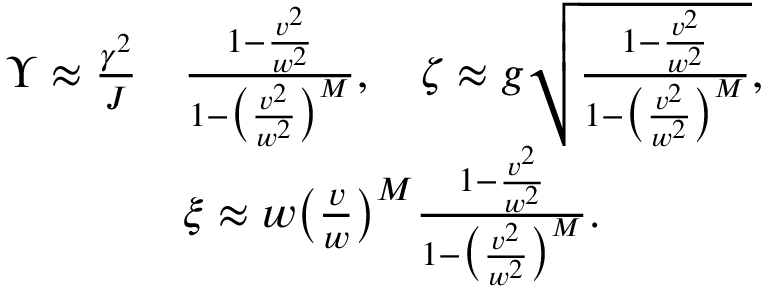<formula> <loc_0><loc_0><loc_500><loc_500>\begin{array} { r l } { \Upsilon \approx \frac { \gamma ^ { 2 } } { J } } & { \frac { 1 - \frac { v ^ { 2 } } { w ^ { 2 } } } { 1 - \left ( \frac { v ^ { 2 } } { w ^ { 2 } } \right ) ^ { M } } , \quad \zeta \approx g \sqrt { \frac { 1 - \frac { v ^ { 2 } } { w ^ { 2 } } } { 1 - \left ( \frac { v ^ { 2 } } { w ^ { 2 } } \right ) ^ { M } } } , } \\ & { \xi \approx w \left ( \frac { v } { w } \right ) ^ { M } \frac { 1 - \frac { v ^ { 2 } } { w ^ { 2 } } } { 1 - \left ( \frac { v ^ { 2 } } { w ^ { 2 } } \right ) ^ { M } } . } \end{array}</formula> 